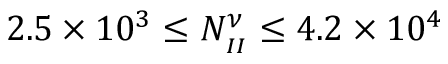<formula> <loc_0><loc_0><loc_500><loc_500>2 . 5 \times 1 0 ^ { 3 } \leq N _ { _ { I I } } ^ { \nu } \leq 4 . 2 \times 1 0 ^ { 4 }</formula> 